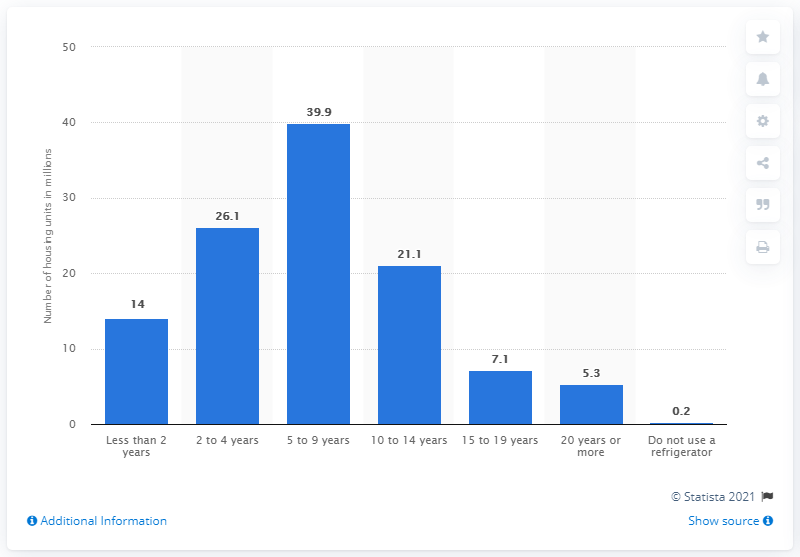Highlight a few significant elements in this photo. Approximately 21.1% of housing units in the United States used a refrigerator that was between 10 and 14 years of age. 